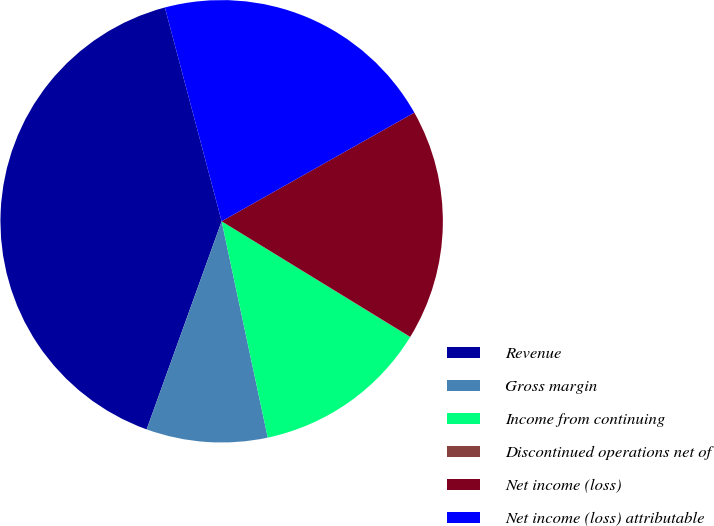Convert chart. <chart><loc_0><loc_0><loc_500><loc_500><pie_chart><fcel>Revenue<fcel>Gross margin<fcel>Income from continuing<fcel>Discontinued operations net of<fcel>Net income (loss)<fcel>Net income (loss) attributable<nl><fcel>40.36%<fcel>8.85%<fcel>12.89%<fcel>0.02%<fcel>16.92%<fcel>20.96%<nl></chart> 